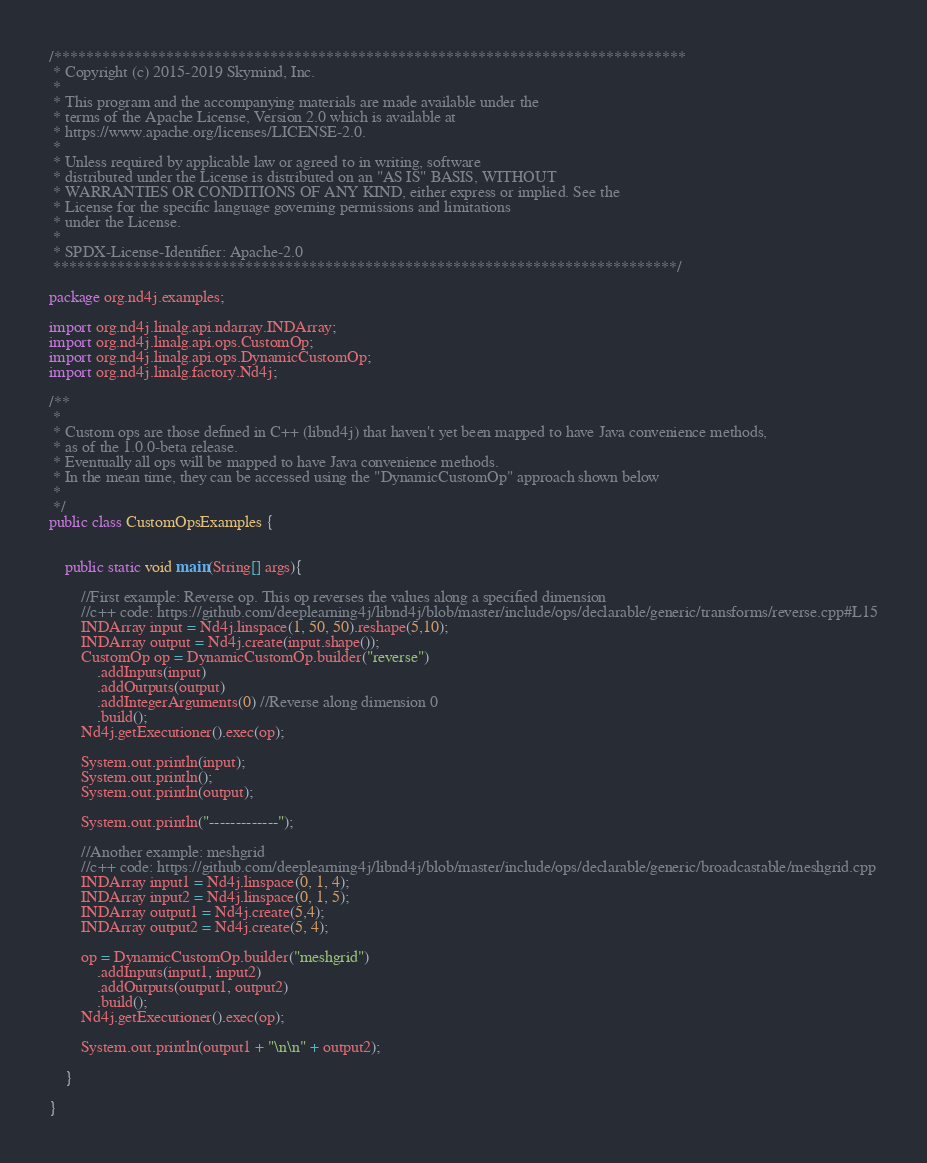Convert code to text. <code><loc_0><loc_0><loc_500><loc_500><_Java_>/*******************************************************************************
 * Copyright (c) 2015-2019 Skymind, Inc.
 *
 * This program and the accompanying materials are made available under the
 * terms of the Apache License, Version 2.0 which is available at
 * https://www.apache.org/licenses/LICENSE-2.0.
 *
 * Unless required by applicable law or agreed to in writing, software
 * distributed under the License is distributed on an "AS IS" BASIS, WITHOUT
 * WARRANTIES OR CONDITIONS OF ANY KIND, either express or implied. See the
 * License for the specific language governing permissions and limitations
 * under the License.
 *
 * SPDX-License-Identifier: Apache-2.0
 ******************************************************************************/

package org.nd4j.examples;

import org.nd4j.linalg.api.ndarray.INDArray;
import org.nd4j.linalg.api.ops.CustomOp;
import org.nd4j.linalg.api.ops.DynamicCustomOp;
import org.nd4j.linalg.factory.Nd4j;

/**
 *
 * Custom ops are those defined in C++ (libnd4j) that haven't yet been mapped to have Java convenience methods,
 * as of the 1.0.0-beta release.
 * Eventually all ops will be mapped to have Java convenience methods.
 * In the mean time, they can be accessed using the "DynamicCustomOp" approach shown below
 *
 */
public class CustomOpsExamples {


    public static void main(String[] args){

        //First example: Reverse op. This op reverses the values along a specified dimension
        //c++ code: https://github.com/deeplearning4j/libnd4j/blob/master/include/ops/declarable/generic/transforms/reverse.cpp#L15
        INDArray input = Nd4j.linspace(1, 50, 50).reshape(5,10);
        INDArray output = Nd4j.create(input.shape());
        CustomOp op = DynamicCustomOp.builder("reverse")
            .addInputs(input)
            .addOutputs(output)
            .addIntegerArguments(0) //Reverse along dimension 0
            .build();
        Nd4j.getExecutioner().exec(op);

        System.out.println(input);
        System.out.println();
        System.out.println(output);

        System.out.println("-------------");

        //Another example: meshgrid
        //c++ code: https://github.com/deeplearning4j/libnd4j/blob/master/include/ops/declarable/generic/broadcastable/meshgrid.cpp
        INDArray input1 = Nd4j.linspace(0, 1, 4);
        INDArray input2 = Nd4j.linspace(0, 1, 5);
        INDArray output1 = Nd4j.create(5,4);
        INDArray output2 = Nd4j.create(5, 4);

        op = DynamicCustomOp.builder("meshgrid")
            .addInputs(input1, input2)
            .addOutputs(output1, output2)
            .build();
        Nd4j.getExecutioner().exec(op);

        System.out.println(output1 + "\n\n" + output2);

    }

}
</code> 